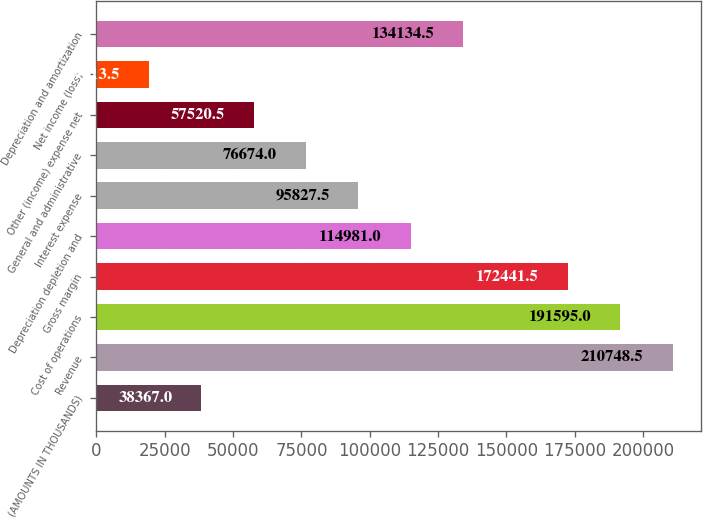<chart> <loc_0><loc_0><loc_500><loc_500><bar_chart><fcel>(AMOUNTS IN THOUSANDS)<fcel>Revenue<fcel>Cost of operations<fcel>Gross margin<fcel>Depreciation depletion and<fcel>Interest expense<fcel>General and administrative<fcel>Other (income) expense net<fcel>Net income (loss)<fcel>Depreciation and amortization<nl><fcel>38367<fcel>210748<fcel>191595<fcel>172442<fcel>114981<fcel>95827.5<fcel>76674<fcel>57520.5<fcel>19213.5<fcel>134134<nl></chart> 